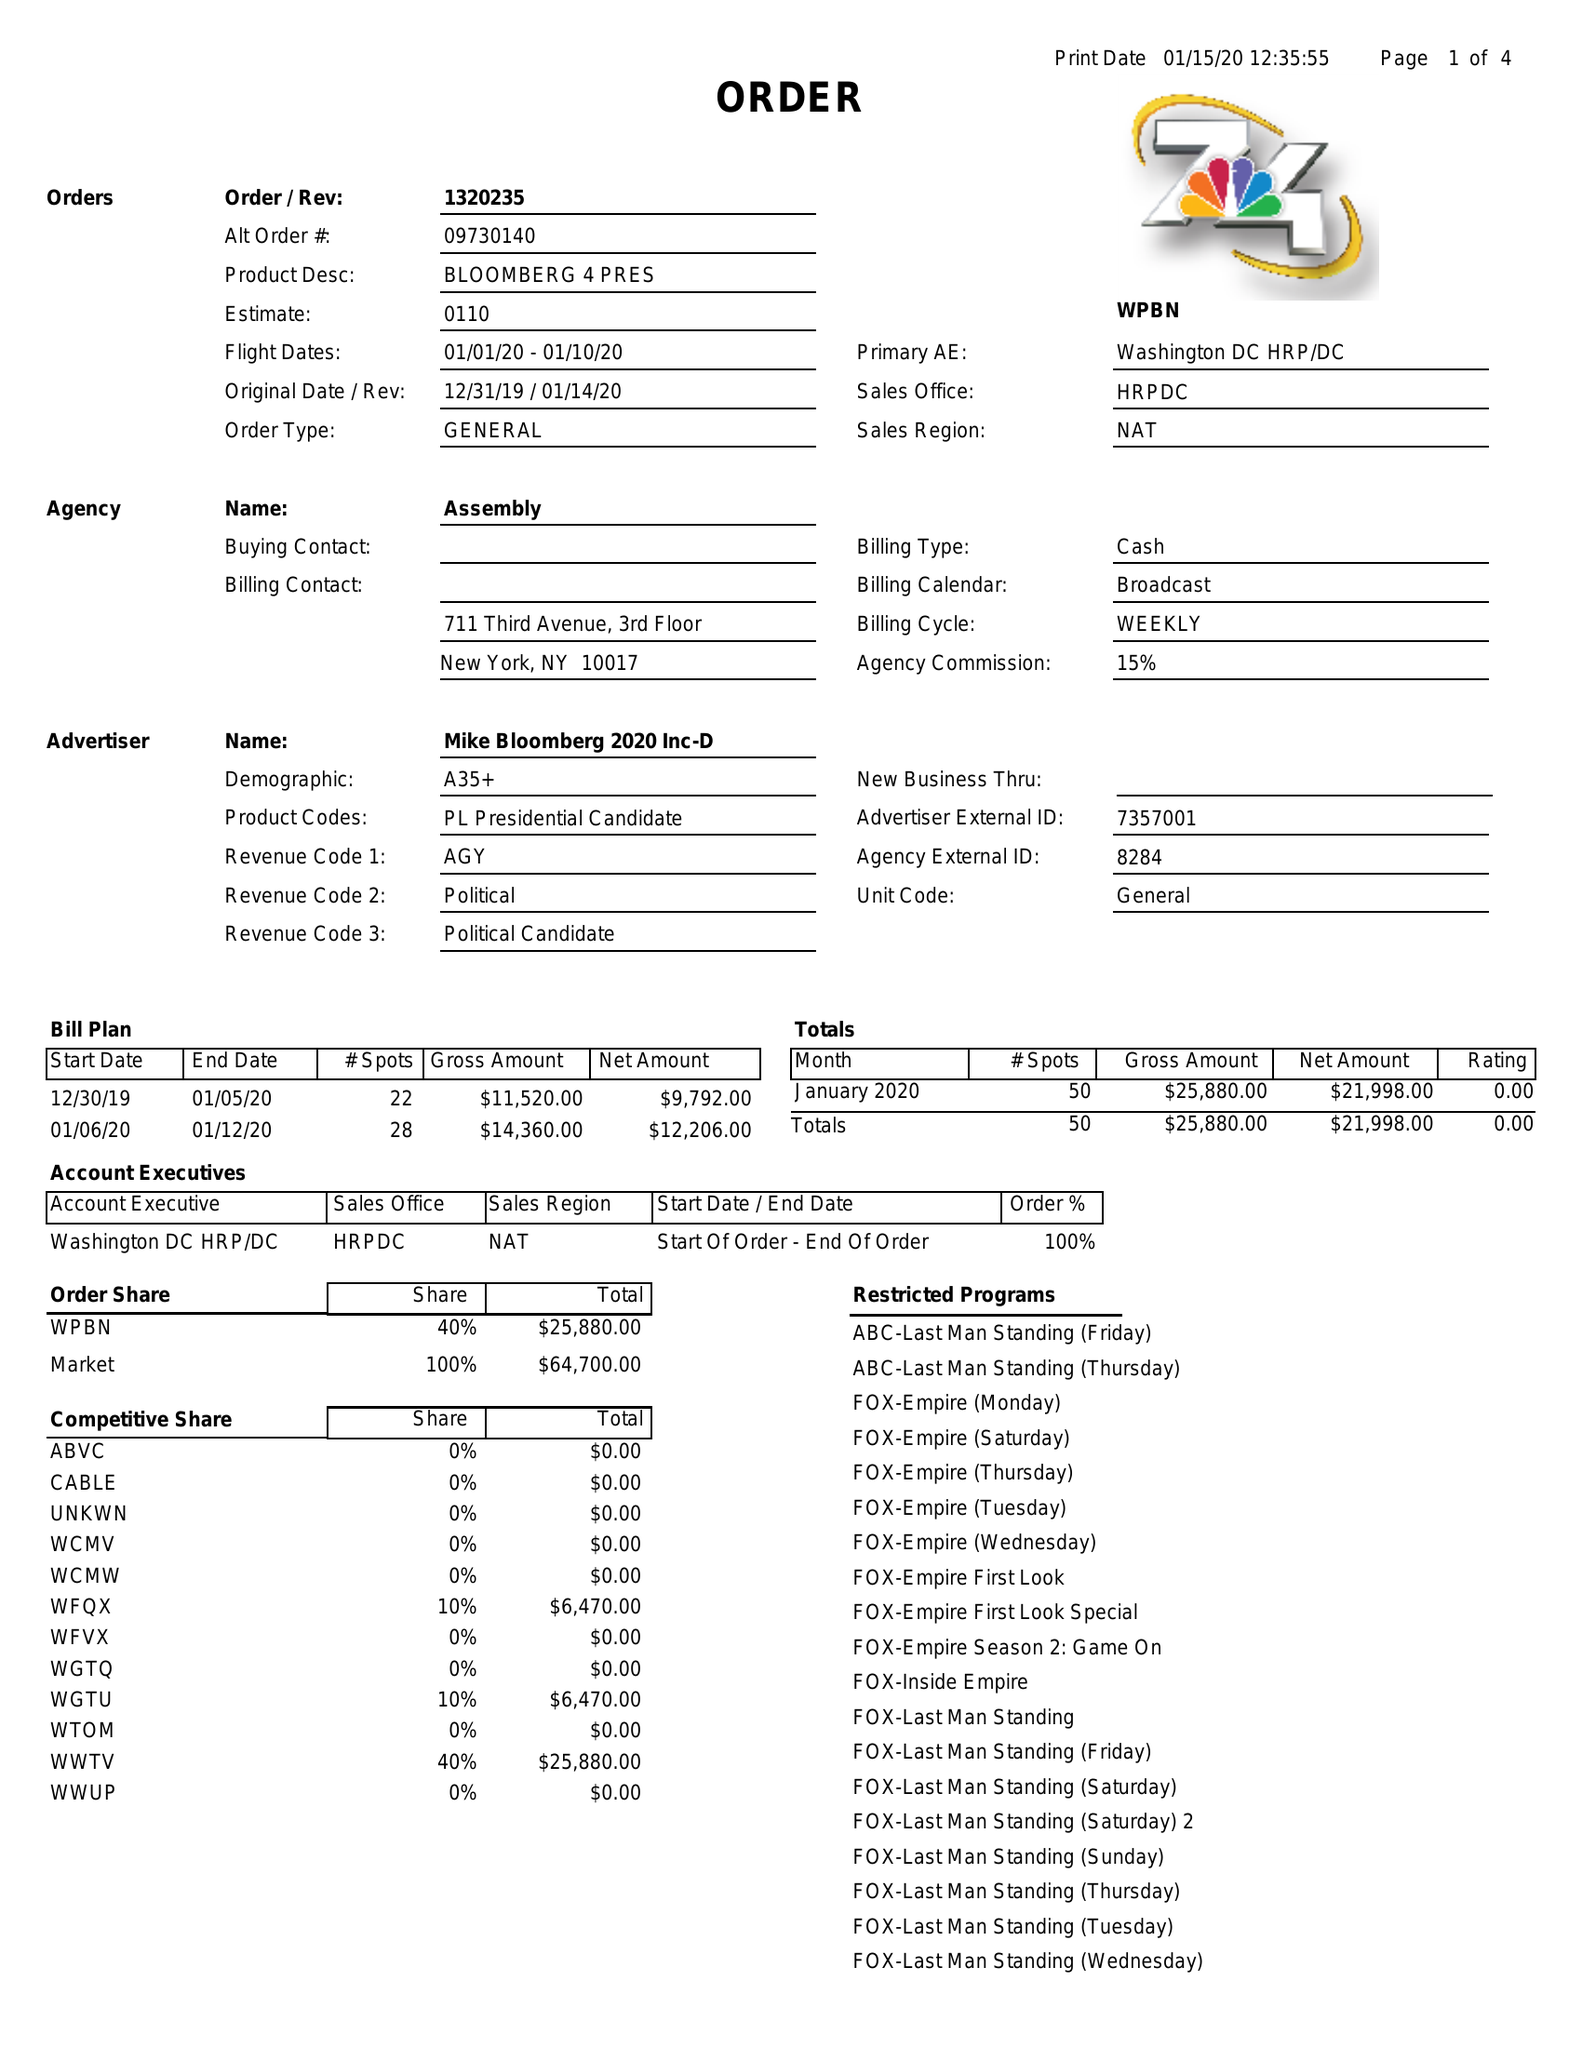What is the value for the advertiser?
Answer the question using a single word or phrase. MIKE BLOOMBERG 2020 INC-D 